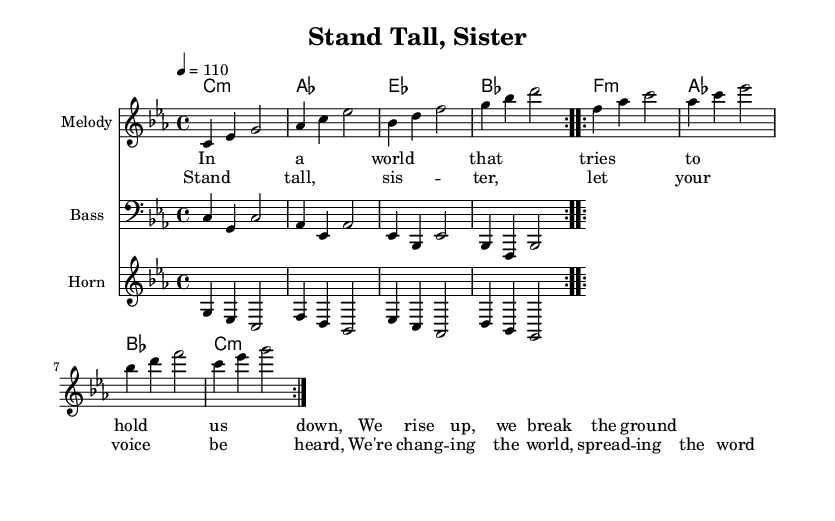What is the key signature of this music? The key signature is C minor, which includes three flats (B♭, E♭, and A♭).
Answer: C minor What is the time signature of this piece? The time signature indicates that there are four beats in each measure, as represented by the 4/4 signature at the beginning.
Answer: 4/4 What is the tempo marking for this song? The tempo marking indicates a speed of 110 beats per minute, as shown by "4 = 110".
Answer: 110 How many measures are in the melody section? The melody section consists of two repeated verses, each containing four measures, leading to a total of eight measures in the melody.
Answer: 8 What is the primary theme expressed in the lyrics? The lyrics focus on empowerment and resilience, emphasizing rising up against oppression and letting one's voice be heard.
Answer: Empowerment What is the role of the horn in this piece? The horn plays a supportive and melodic role, providing counter-melody and harmonies that enhance the main melody.
Answer: Supportive How do the chords contribute to the overall mood of the song? The use of minor chords throughout creates a sense of seriousness and depth, which aligns with the themes of struggle and empowerment in the lyrics.
Answer: Seriousness 